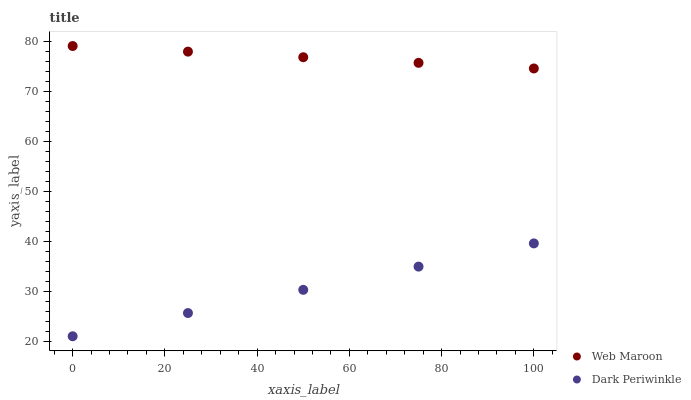Does Dark Periwinkle have the minimum area under the curve?
Answer yes or no. Yes. Does Web Maroon have the maximum area under the curve?
Answer yes or no. Yes. Does Dark Periwinkle have the maximum area under the curve?
Answer yes or no. No. Is Dark Periwinkle the smoothest?
Answer yes or no. Yes. Is Web Maroon the roughest?
Answer yes or no. Yes. Is Dark Periwinkle the roughest?
Answer yes or no. No. Does Dark Periwinkle have the lowest value?
Answer yes or no. Yes. Does Web Maroon have the highest value?
Answer yes or no. Yes. Does Dark Periwinkle have the highest value?
Answer yes or no. No. Is Dark Periwinkle less than Web Maroon?
Answer yes or no. Yes. Is Web Maroon greater than Dark Periwinkle?
Answer yes or no. Yes. Does Dark Periwinkle intersect Web Maroon?
Answer yes or no. No. 